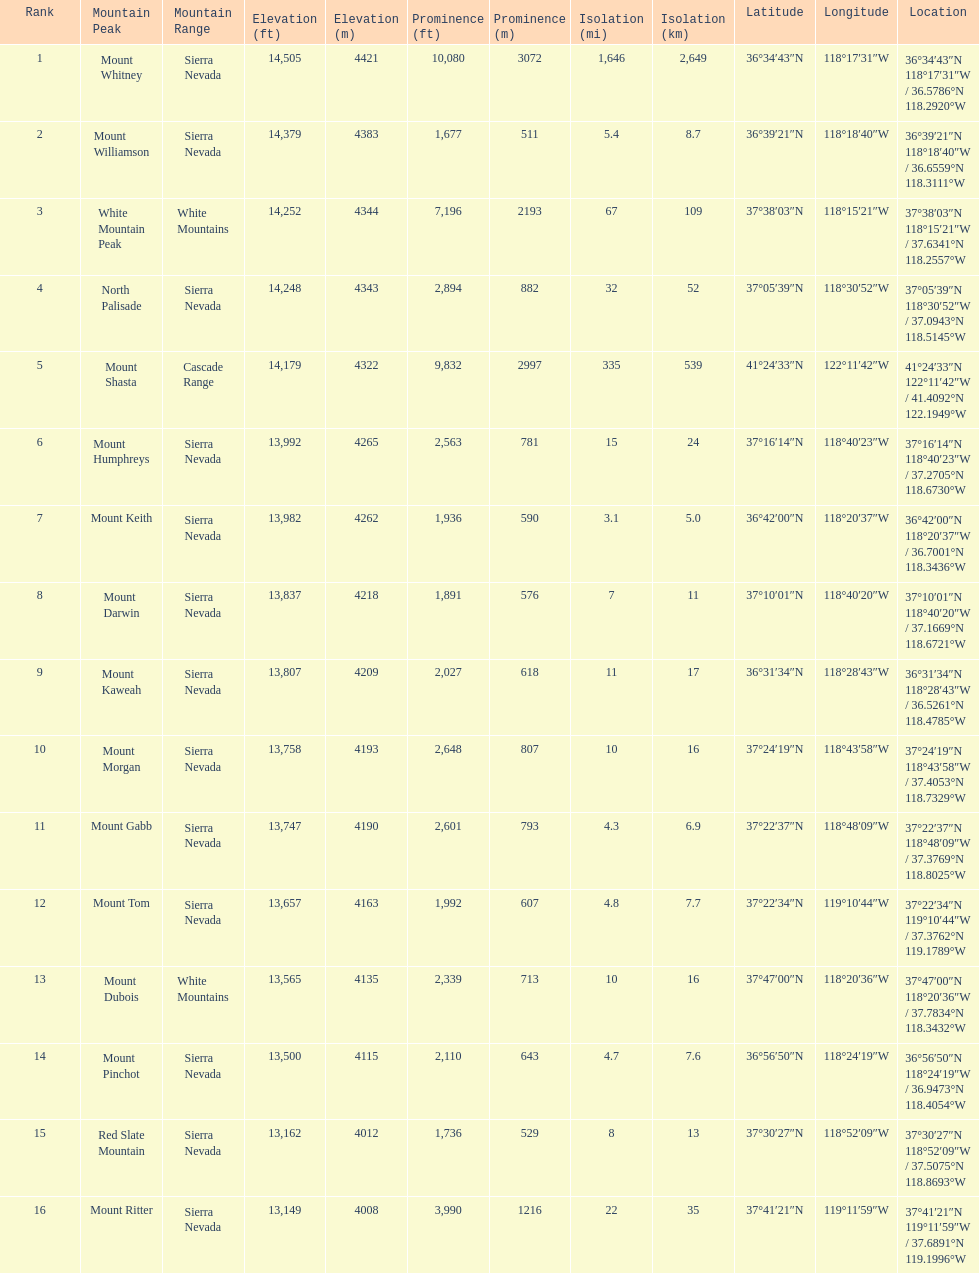In feet, what is the difference between the tallest peak and the 9th tallest peak in california? 698 ft. 